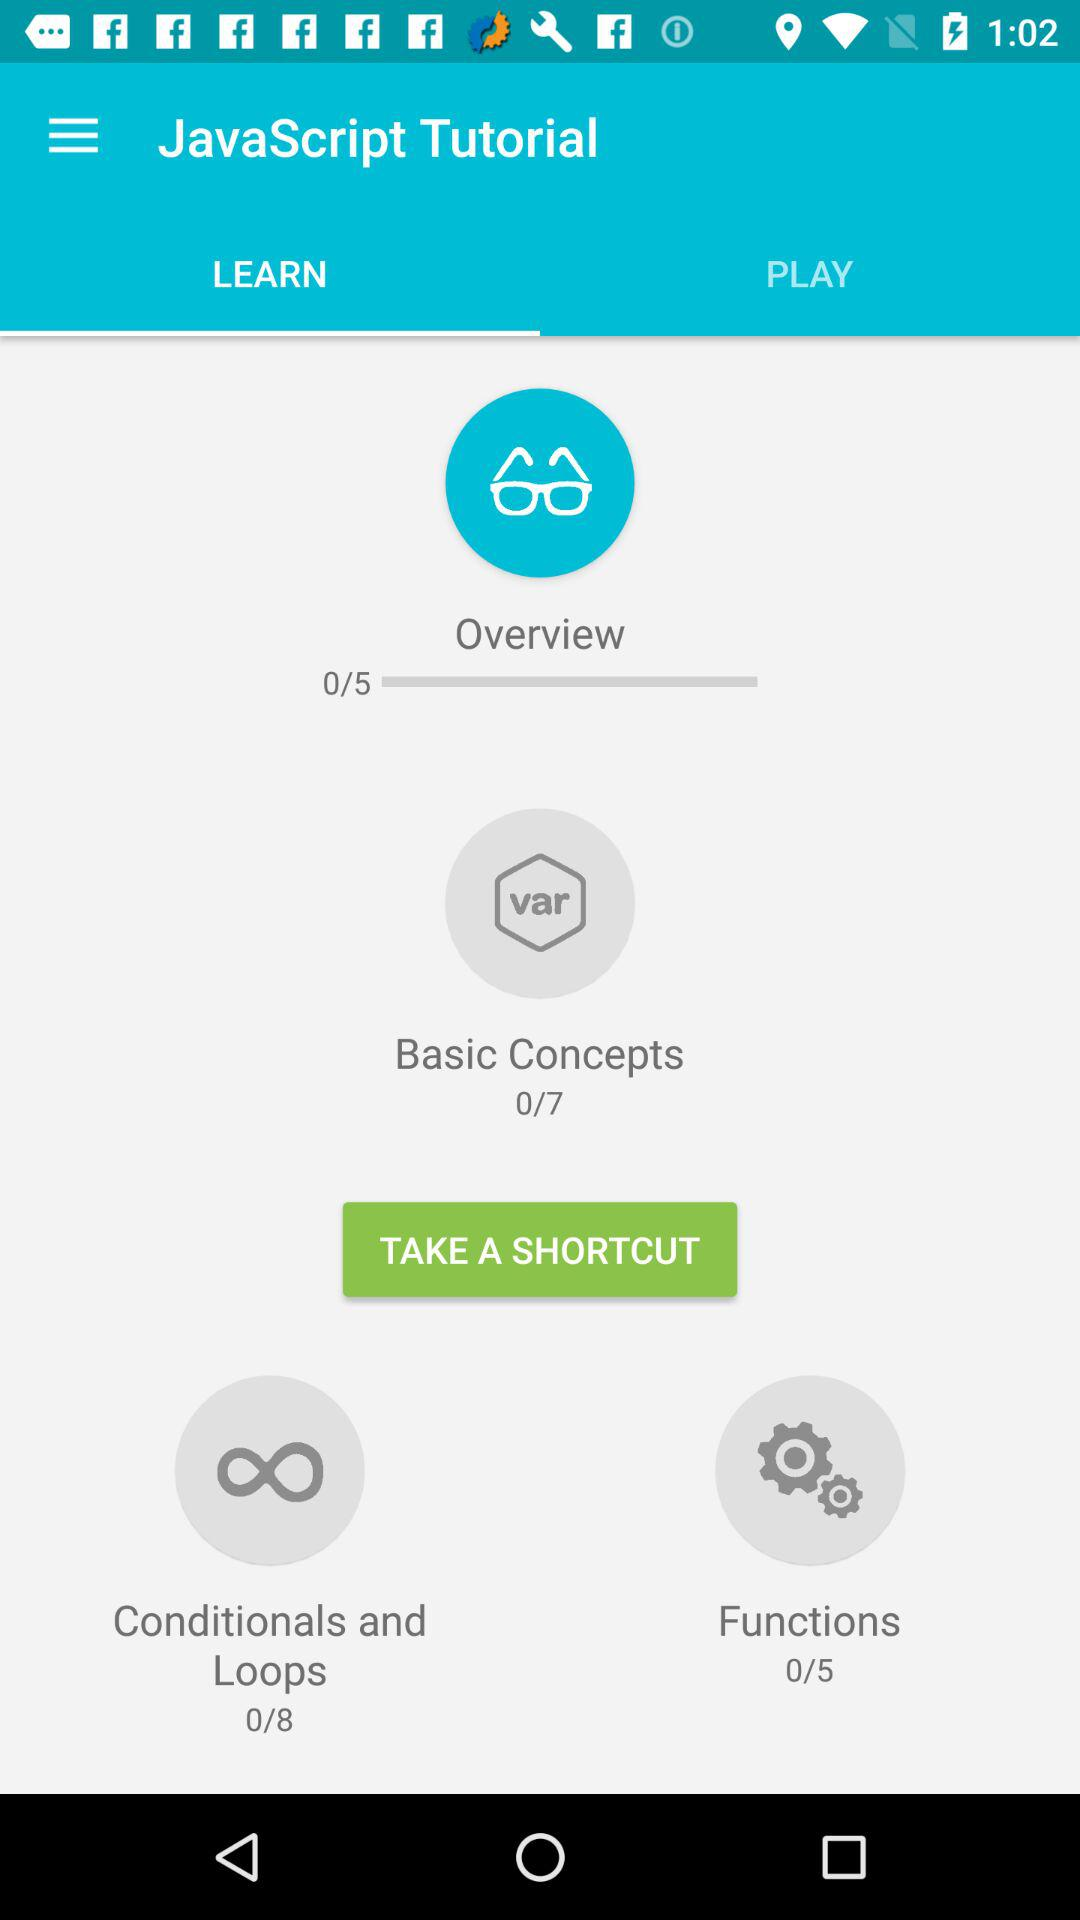Which option is selected in the "JavaScript Tutorial"? The selected option is "LEARN". 